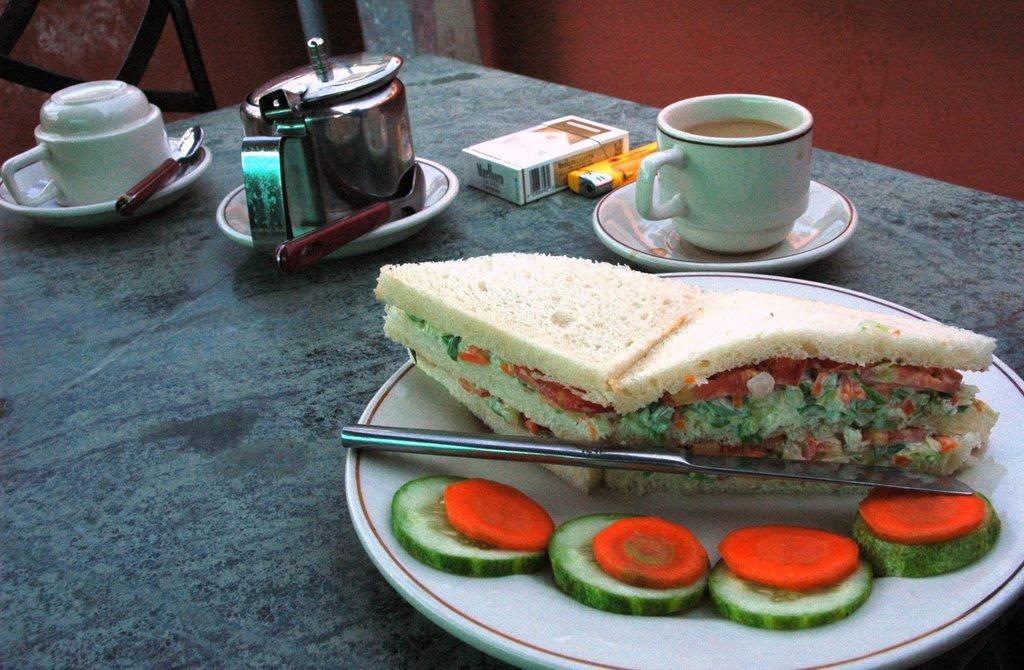Describe this image in one or two sentences. In this picture I can see the plate, tea cup, saucer, cigarette packet, lighter, spoons and other objects on the table. On the right I can see the sandwich, knife, cucumber and carrot pieces in a white plate. In the top left corner there is a chair near to the wall. 